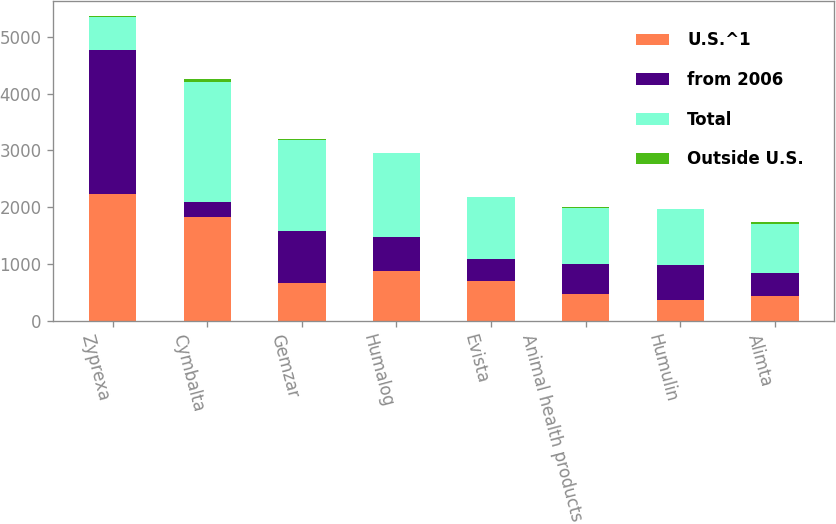<chart> <loc_0><loc_0><loc_500><loc_500><stacked_bar_chart><ecel><fcel>Zyprexa<fcel>Cymbalta<fcel>Gemzar<fcel>Humalog<fcel>Evista<fcel>Animal health products<fcel>Humulin<fcel>Alimta<nl><fcel>U.S.^1<fcel>2236<fcel>1835.6<fcel>670<fcel>888<fcel>706.1<fcel>480.9<fcel>365.2<fcel>448<nl><fcel>from 2006<fcel>2525<fcel>267.3<fcel>922.4<fcel>586.6<fcel>384.6<fcel>514.9<fcel>620<fcel>406<nl><fcel>Total<fcel>586.6<fcel>2102.9<fcel>1592.4<fcel>1474.6<fcel>1090.7<fcel>995.8<fcel>985.2<fcel>854<nl><fcel>Outside U.S.<fcel>9<fcel>60<fcel>13<fcel>13<fcel>4<fcel>14<fcel>6<fcel>40<nl></chart> 